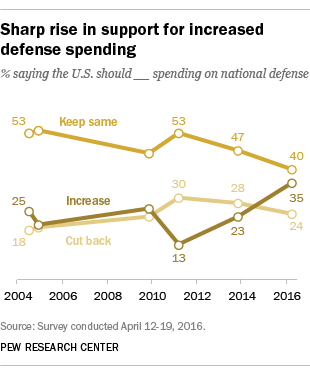Identify some key points in this picture. In 2016, a significant proportion of people asked for defense spending to be reduced. Specifically, 24% of people voiced their support for reducing defense spending. The sum of the cutback and keep-same attitudes in 2012 is 83. 